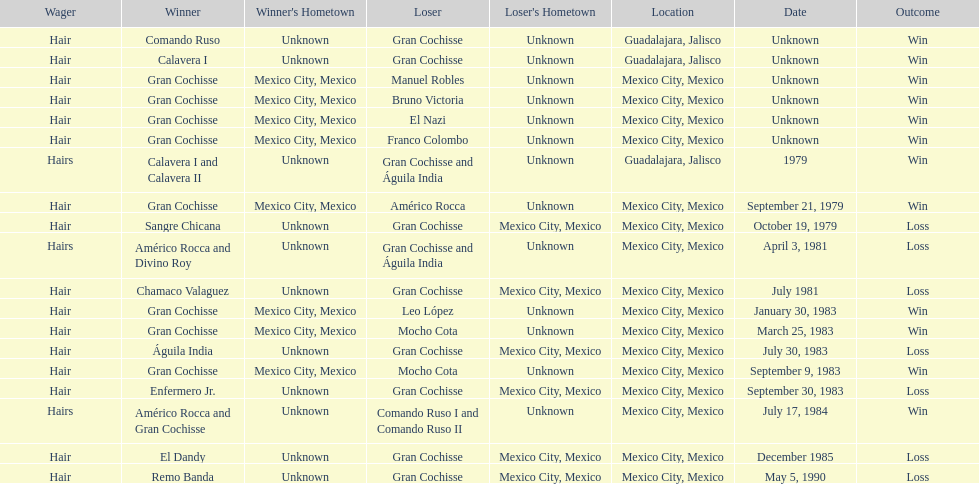When did bruno victoria lose his first game? Unknown. 